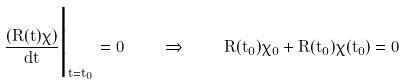<formula> <loc_0><loc_0><loc_500><loc_500>\frac { \left ( R ( t ) \chi \right ) } { d t } \Big | _ { t = t _ { 0 } } = 0 \quad \Rightarrow \quad \dot { R } ( t _ { 0 } ) \chi _ { 0 } + R ( t _ { 0 } ) \dot { \chi } ( t _ { 0 } ) = 0</formula> 